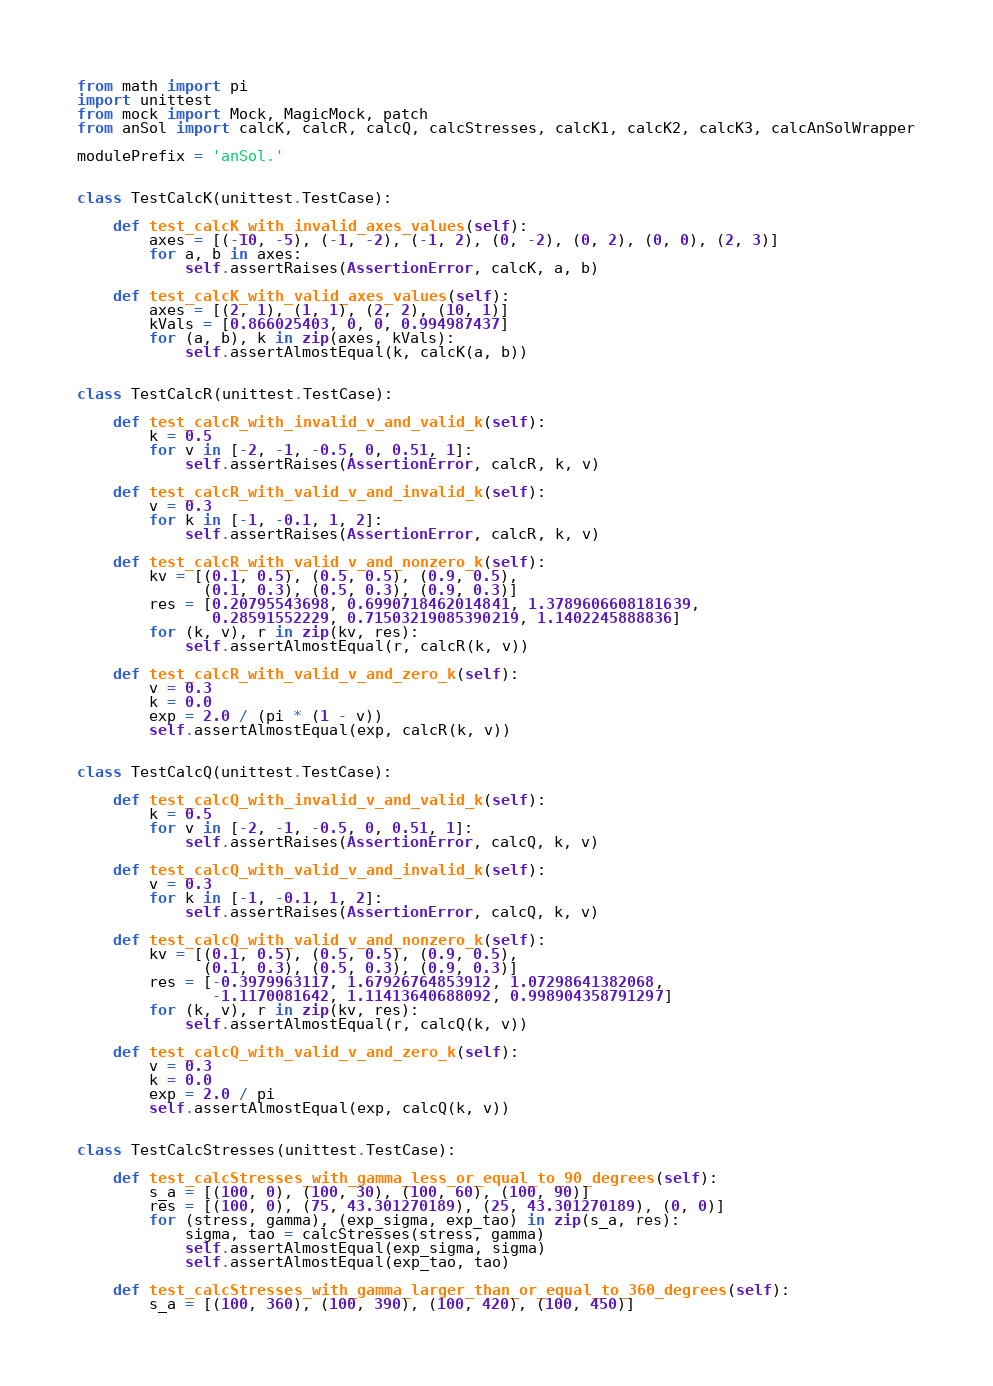<code> <loc_0><loc_0><loc_500><loc_500><_Python_>from math import pi
import unittest
from mock import Mock, MagicMock, patch
from anSol import calcK, calcR, calcQ, calcStresses, calcK1, calcK2, calcK3, calcAnSolWrapper

modulePrefix = 'anSol.'


class TestCalcK(unittest.TestCase):

    def test_calcK_with_invalid_axes_values(self):
        axes = [(-10, -5), (-1, -2), (-1, 2), (0, -2), (0, 2), (0, 0), (2, 3)]
        for a, b in axes:
            self.assertRaises(AssertionError, calcK, a, b)

    def test_calcK_with_valid_axes_values(self):
        axes = [(2, 1), (1, 1), (2, 2), (10, 1)]
        kVals = [0.866025403, 0, 0, 0.994987437]
        for (a, b), k in zip(axes, kVals):
            self.assertAlmostEqual(k, calcK(a, b))


class TestCalcR(unittest.TestCase):

    def test_calcR_with_invalid_v_and_valid_k(self):
        k = 0.5
        for v in [-2, -1, -0.5, 0, 0.51, 1]:
            self.assertRaises(AssertionError, calcR, k, v)

    def test_calcR_with_valid_v_and_invalid_k(self):
        v = 0.3
        for k in [-1, -0.1, 1, 2]:
            self.assertRaises(AssertionError, calcR, k, v)

    def test_calcR_with_valid_v_and_nonzero_k(self):
        kv = [(0.1, 0.5), (0.5, 0.5), (0.9, 0.5),
              (0.1, 0.3), (0.5, 0.3), (0.9, 0.3)]
        res = [0.20795543698, 0.6990718462014841, 1.3789606608181639,
               0.28591552229, 0.71503219085390219, 1.1402245888836]
        for (k, v), r in zip(kv, res):
            self.assertAlmostEqual(r, calcR(k, v))

    def test_calcR_with_valid_v_and_zero_k(self):
        v = 0.3
        k = 0.0
        exp = 2.0 / (pi * (1 - v))
        self.assertAlmostEqual(exp, calcR(k, v))


class TestCalcQ(unittest.TestCase):

    def test_calcQ_with_invalid_v_and_valid_k(self):
        k = 0.5
        for v in [-2, -1, -0.5, 0, 0.51, 1]:
            self.assertRaises(AssertionError, calcQ, k, v)

    def test_calcQ_with_valid_v_and_invalid_k(self):
        v = 0.3
        for k in [-1, -0.1, 1, 2]:
            self.assertRaises(AssertionError, calcQ, k, v)

    def test_calcQ_with_valid_v_and_nonzero_k(self):
        kv = [(0.1, 0.5), (0.5, 0.5), (0.9, 0.5),
              (0.1, 0.3), (0.5, 0.3), (0.9, 0.3)]
        res = [-0.3979963117, 1.67926764853912, 1.07298641382068,
               -1.1170081642, 1.11413640688092, 0.998904358791297]
        for (k, v), r in zip(kv, res):
            self.assertAlmostEqual(r, calcQ(k, v))

    def test_calcQ_with_valid_v_and_zero_k(self):
        v = 0.3
        k = 0.0
        exp = 2.0 / pi
        self.assertAlmostEqual(exp, calcQ(k, v))


class TestCalcStresses(unittest.TestCase):

    def test_calcStresses_with_gamma_less_or_equal_to_90_degrees(self):
        s_a = [(100, 0), (100, 30), (100, 60), (100, 90)]
        res = [(100, 0), (75, 43.301270189), (25, 43.301270189), (0, 0)]
        for (stress, gamma), (exp_sigma, exp_tao) in zip(s_a, res):
            sigma, tao = calcStresses(stress, gamma)
            self.assertAlmostEqual(exp_sigma, sigma)
            self.assertAlmostEqual(exp_tao, tao)

    def test_calcStresses_with_gamma_larger_than_or_equal_to_360_degrees(self):
        s_a = [(100, 360), (100, 390), (100, 420), (100, 450)]</code> 